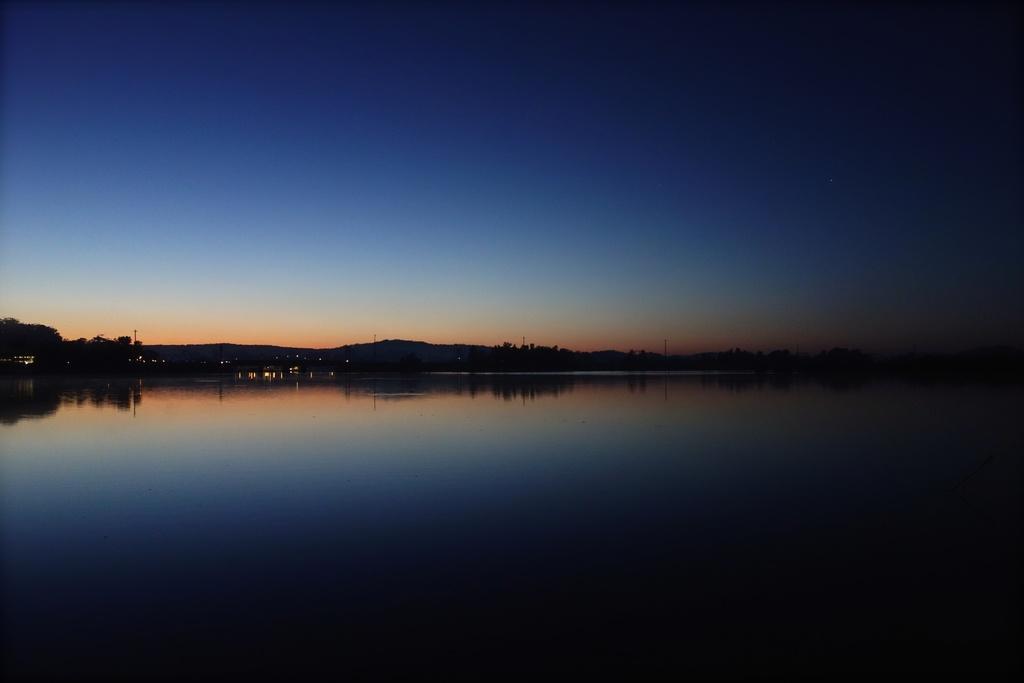Please provide a concise description of this image. In this image we can see the water and mountains. At the top we can see the sky. On the water we can see the reflection of the sky and the mountains. 